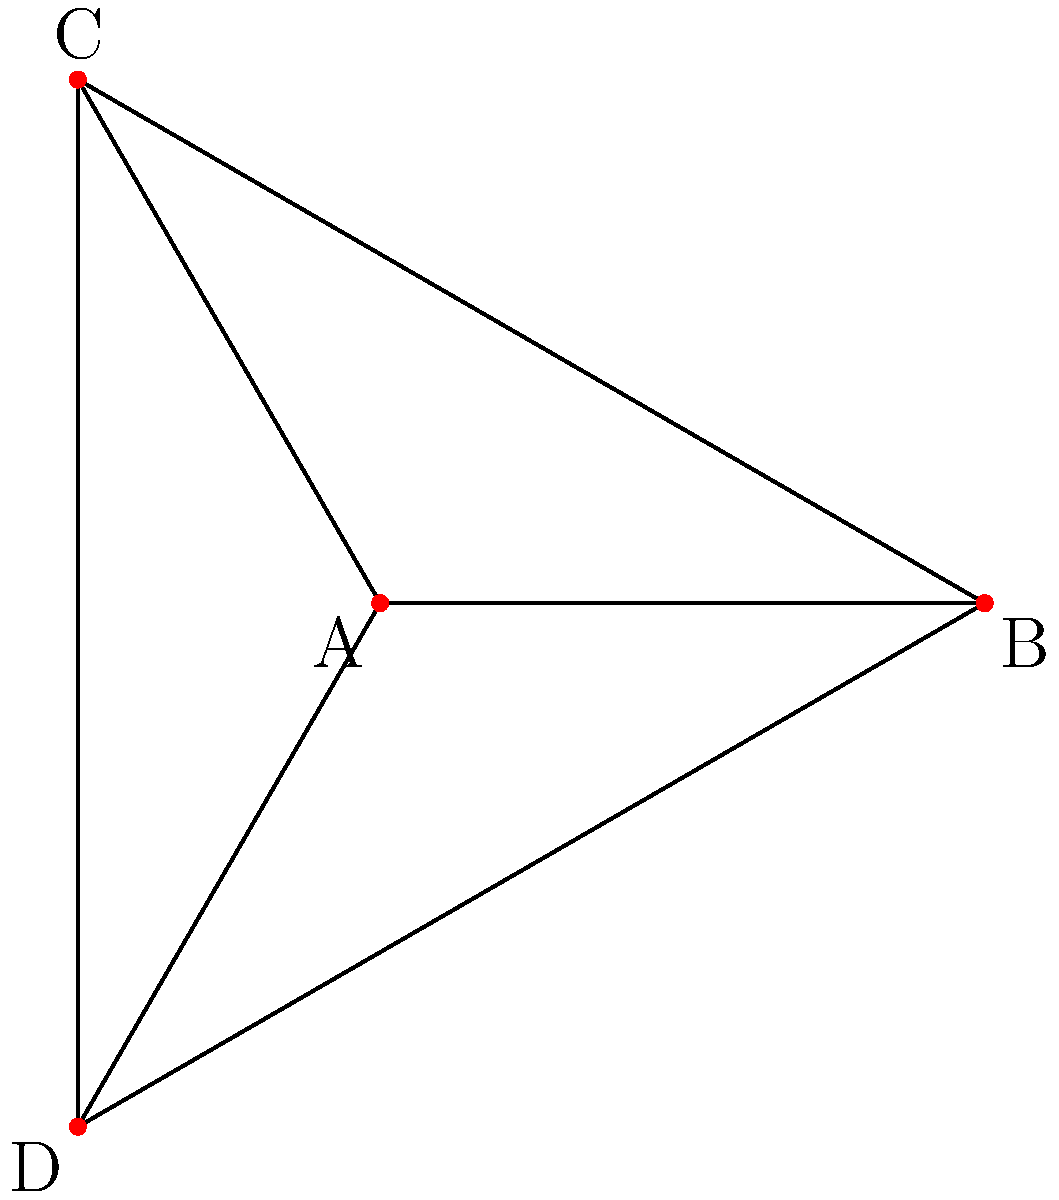In a border region with four areas (A, B, C, and D) as shown in the graph, where each area shares a border with every other area, what is the minimum number of colors needed to color the map so that no two adjacent areas have the same color? How does this relate to the concept of chromatic number in graph theory? To solve this problem, we'll follow these steps:

1. Understand the graph:
   - We have 4 vertices (A, B, C, D) representing the areas.
   - Each vertex is connected to every other vertex, forming a complete graph $K_4$.

2. Recall the concept of chromatic number:
   - The chromatic number $\chi(G)$ of a graph G is the minimum number of colors needed to color the vertices so that no two adjacent vertices have the same color.

3. Analyze the graph:
   - In a complete graph with n vertices, every vertex is adjacent to every other vertex.
   - This means each vertex must have a different color.

4. Determine the chromatic number:
   - For a complete graph $K_n$, the chromatic number is always n.
   - In this case, we have $K_4$, so $\chi(K_4) = 4$.

5. Relate to the border region problem:
   - Each area (vertex) must have a different color from all other areas.
   - Therefore, we need a minimum of 4 colors to properly color the map.

6. Consider the implications for cross-border cooperation:
   - The high chromatic number indicates a complex situation where each area has unique considerations.
   - This emphasizes the need for open dialogue and cooperation to manage potential conflicts.
Answer: 4 colors; $\chi(K_4) = 4$ 